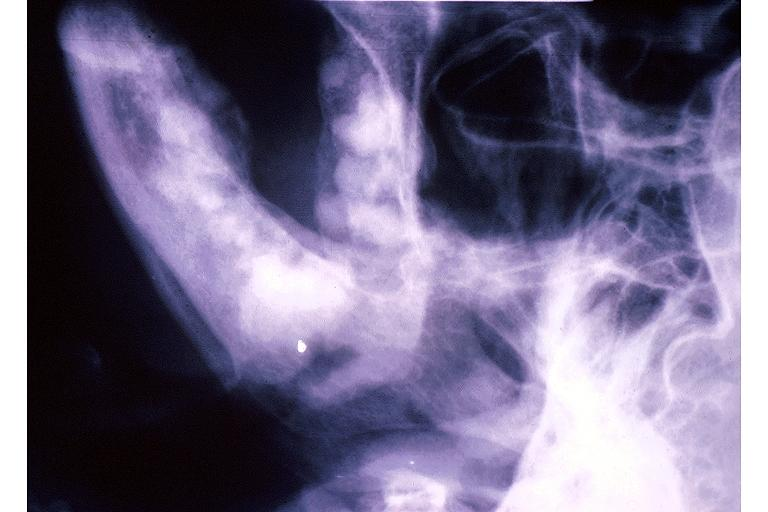s primary present?
Answer the question using a single word or phrase. No 